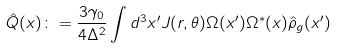Convert formula to latex. <formula><loc_0><loc_0><loc_500><loc_500>\hat { Q } ( { x } ) \colon = \frac { 3 \gamma _ { 0 } } { 4 \Delta ^ { 2 } } \int d ^ { 3 } x ^ { \prime } J ( r , \theta ) \Omega ( { x } ^ { \prime } ) \Omega ^ { * } ( { x } ) \hat { \rho } _ { g } ( { x } ^ { \prime } )</formula> 